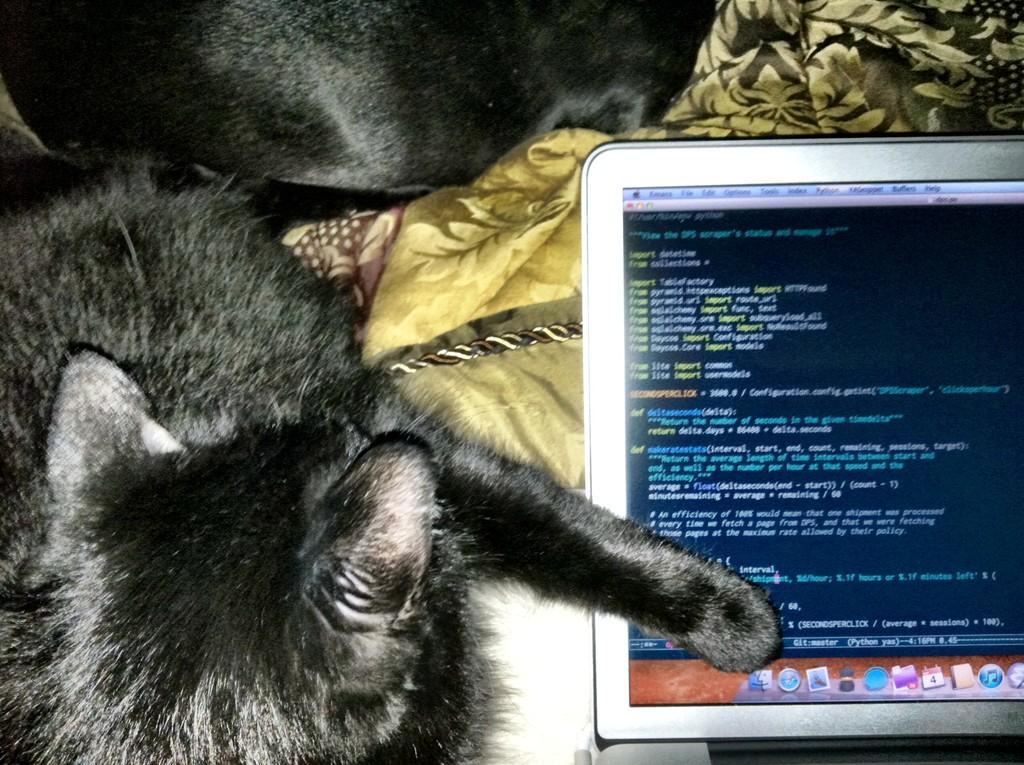Describe this image in one or two sentences. This image consists of two pets in black color. On the right, there is a laptop. At the bottom, there is a bed along with bed sheets. 